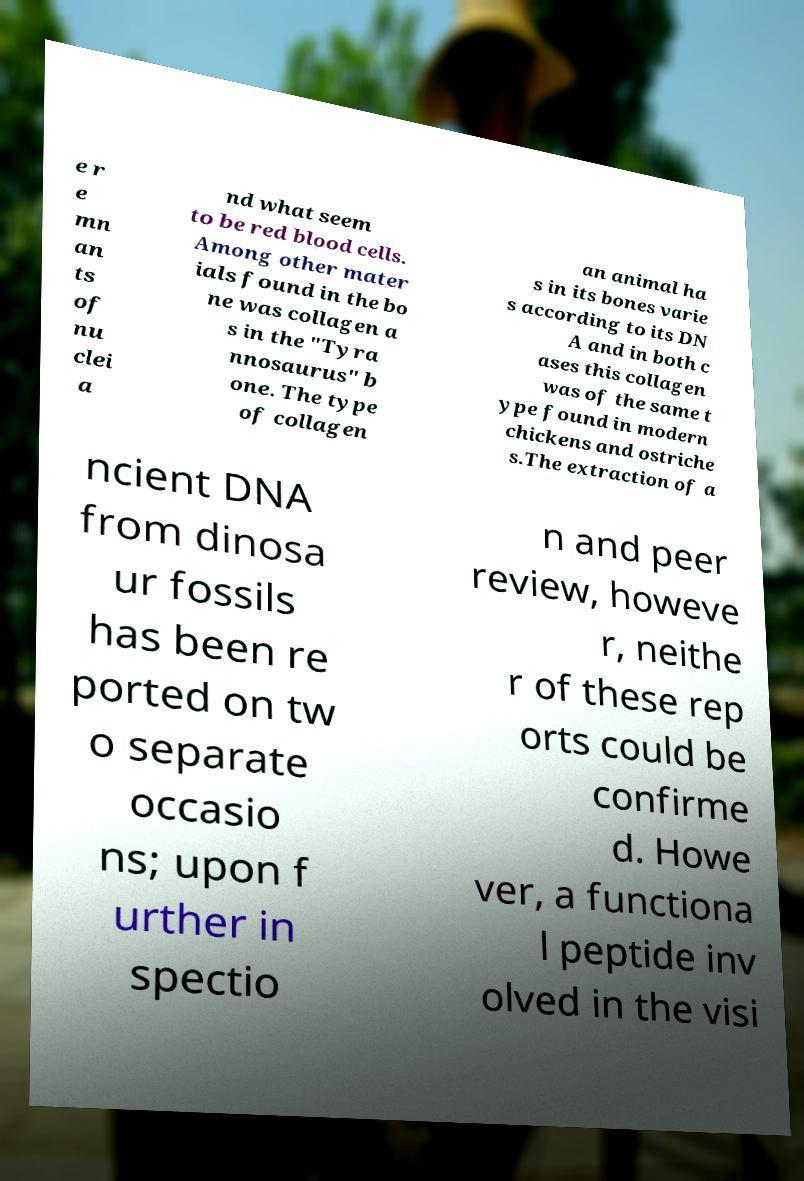Can you read and provide the text displayed in the image?This photo seems to have some interesting text. Can you extract and type it out for me? e r e mn an ts of nu clei a nd what seem to be red blood cells. Among other mater ials found in the bo ne was collagen a s in the "Tyra nnosaurus" b one. The type of collagen an animal ha s in its bones varie s according to its DN A and in both c ases this collagen was of the same t ype found in modern chickens and ostriche s.The extraction of a ncient DNA from dinosa ur fossils has been re ported on tw o separate occasio ns; upon f urther in spectio n and peer review, howeve r, neithe r of these rep orts could be confirme d. Howe ver, a functiona l peptide inv olved in the visi 